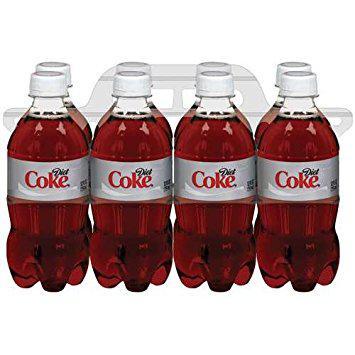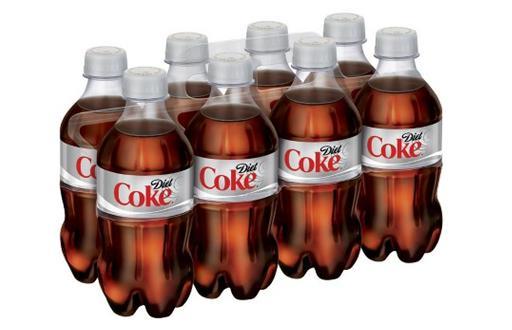The first image is the image on the left, the second image is the image on the right. Given the left and right images, does the statement "There are only eight bottles of diet coke in the image to the right; there are no extra, loose bottles." hold true? Answer yes or no. Yes. The first image is the image on the left, the second image is the image on the right. For the images shown, is this caption "Each image shows a multipack of eight soda bottles with non-black caps and no box packaging, and the labels of the bottles in the right and left images are nearly identical." true? Answer yes or no. Yes. 